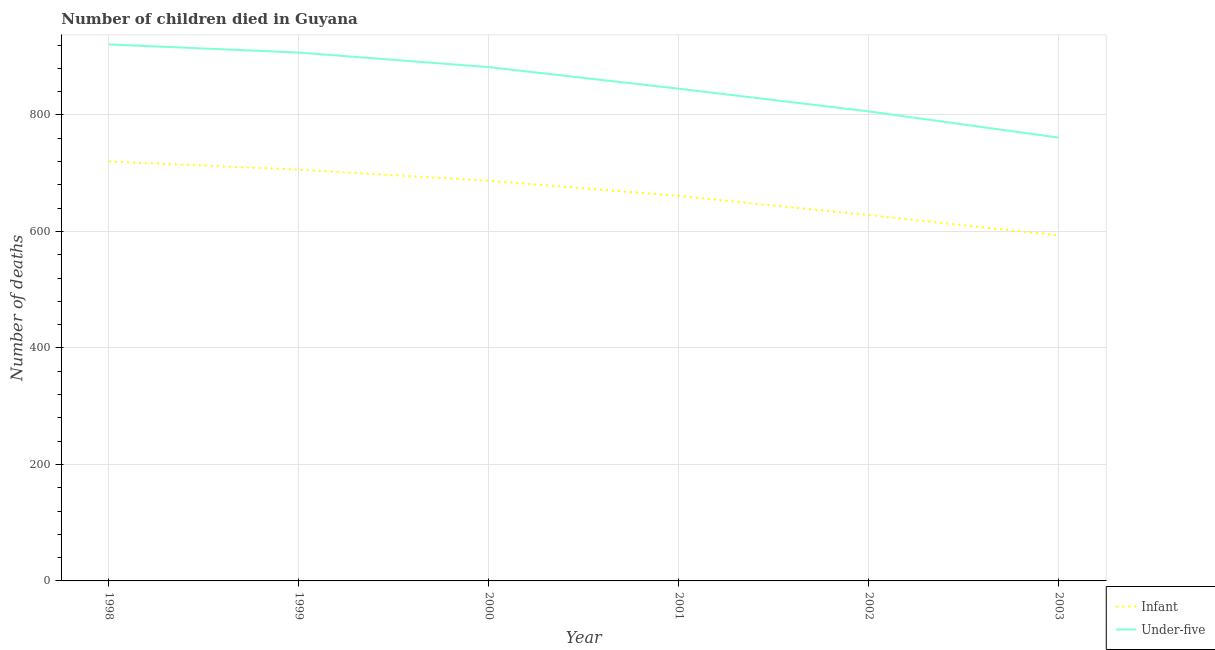Does the line corresponding to number of infant deaths intersect with the line corresponding to number of under-five deaths?
Make the answer very short. No. Is the number of lines equal to the number of legend labels?
Make the answer very short. Yes. What is the number of under-five deaths in 2002?
Your answer should be very brief. 806. Across all years, what is the maximum number of under-five deaths?
Your answer should be compact. 921. Across all years, what is the minimum number of under-five deaths?
Your answer should be very brief. 761. In which year was the number of under-five deaths minimum?
Make the answer very short. 2003. What is the total number of infant deaths in the graph?
Make the answer very short. 3995. What is the difference between the number of infant deaths in 1999 and that in 2002?
Keep it short and to the point. 78. What is the difference between the number of infant deaths in 1999 and the number of under-five deaths in 2001?
Provide a short and direct response. -139. What is the average number of under-five deaths per year?
Make the answer very short. 853.67. In the year 1998, what is the difference between the number of infant deaths and number of under-five deaths?
Your response must be concise. -201. What is the ratio of the number of under-five deaths in 2000 to that in 2002?
Ensure brevity in your answer.  1.09. Is the number of under-five deaths in 1999 less than that in 2000?
Your response must be concise. No. What is the difference between the highest and the lowest number of under-five deaths?
Give a very brief answer. 160. Is the sum of the number of under-five deaths in 2000 and 2003 greater than the maximum number of infant deaths across all years?
Offer a terse response. Yes. Does the number of infant deaths monotonically increase over the years?
Provide a succinct answer. No. Is the number of under-five deaths strictly less than the number of infant deaths over the years?
Your response must be concise. No. How many lines are there?
Your answer should be compact. 2. How many years are there in the graph?
Make the answer very short. 6. Does the graph contain any zero values?
Provide a short and direct response. No. How many legend labels are there?
Ensure brevity in your answer.  2. How are the legend labels stacked?
Give a very brief answer. Vertical. What is the title of the graph?
Keep it short and to the point. Number of children died in Guyana. What is the label or title of the Y-axis?
Offer a terse response. Number of deaths. What is the Number of deaths of Infant in 1998?
Make the answer very short. 720. What is the Number of deaths of Under-five in 1998?
Provide a succinct answer. 921. What is the Number of deaths of Infant in 1999?
Make the answer very short. 706. What is the Number of deaths in Under-five in 1999?
Your answer should be compact. 907. What is the Number of deaths of Infant in 2000?
Your response must be concise. 687. What is the Number of deaths of Under-five in 2000?
Offer a terse response. 882. What is the Number of deaths of Infant in 2001?
Give a very brief answer. 661. What is the Number of deaths of Under-five in 2001?
Keep it short and to the point. 845. What is the Number of deaths of Infant in 2002?
Offer a terse response. 628. What is the Number of deaths in Under-five in 2002?
Make the answer very short. 806. What is the Number of deaths of Infant in 2003?
Provide a short and direct response. 593. What is the Number of deaths in Under-five in 2003?
Provide a succinct answer. 761. Across all years, what is the maximum Number of deaths in Infant?
Keep it short and to the point. 720. Across all years, what is the maximum Number of deaths of Under-five?
Keep it short and to the point. 921. Across all years, what is the minimum Number of deaths in Infant?
Ensure brevity in your answer.  593. Across all years, what is the minimum Number of deaths in Under-five?
Keep it short and to the point. 761. What is the total Number of deaths in Infant in the graph?
Provide a succinct answer. 3995. What is the total Number of deaths in Under-five in the graph?
Offer a terse response. 5122. What is the difference between the Number of deaths in Infant in 1998 and that in 1999?
Offer a terse response. 14. What is the difference between the Number of deaths in Infant in 1998 and that in 2001?
Make the answer very short. 59. What is the difference between the Number of deaths in Under-five in 1998 and that in 2001?
Give a very brief answer. 76. What is the difference between the Number of deaths of Infant in 1998 and that in 2002?
Your answer should be compact. 92. What is the difference between the Number of deaths of Under-five in 1998 and that in 2002?
Offer a very short reply. 115. What is the difference between the Number of deaths in Infant in 1998 and that in 2003?
Provide a succinct answer. 127. What is the difference between the Number of deaths in Under-five in 1998 and that in 2003?
Offer a terse response. 160. What is the difference between the Number of deaths of Infant in 1999 and that in 2000?
Provide a succinct answer. 19. What is the difference between the Number of deaths of Under-five in 1999 and that in 2000?
Your answer should be compact. 25. What is the difference between the Number of deaths in Infant in 1999 and that in 2001?
Provide a short and direct response. 45. What is the difference between the Number of deaths of Under-five in 1999 and that in 2001?
Keep it short and to the point. 62. What is the difference between the Number of deaths in Infant in 1999 and that in 2002?
Your response must be concise. 78. What is the difference between the Number of deaths in Under-five in 1999 and that in 2002?
Your answer should be very brief. 101. What is the difference between the Number of deaths of Infant in 1999 and that in 2003?
Your response must be concise. 113. What is the difference between the Number of deaths in Under-five in 1999 and that in 2003?
Ensure brevity in your answer.  146. What is the difference between the Number of deaths in Infant in 2000 and that in 2001?
Your response must be concise. 26. What is the difference between the Number of deaths of Under-five in 2000 and that in 2002?
Keep it short and to the point. 76. What is the difference between the Number of deaths in Infant in 2000 and that in 2003?
Your answer should be very brief. 94. What is the difference between the Number of deaths in Under-five in 2000 and that in 2003?
Your answer should be very brief. 121. What is the difference between the Number of deaths of Infant in 2001 and that in 2002?
Ensure brevity in your answer.  33. What is the difference between the Number of deaths in Under-five in 2001 and that in 2002?
Offer a terse response. 39. What is the difference between the Number of deaths in Infant in 2001 and that in 2003?
Your response must be concise. 68. What is the difference between the Number of deaths of Under-five in 2001 and that in 2003?
Offer a very short reply. 84. What is the difference between the Number of deaths in Infant in 1998 and the Number of deaths in Under-five in 1999?
Offer a terse response. -187. What is the difference between the Number of deaths of Infant in 1998 and the Number of deaths of Under-five in 2000?
Your response must be concise. -162. What is the difference between the Number of deaths in Infant in 1998 and the Number of deaths in Under-five in 2001?
Provide a succinct answer. -125. What is the difference between the Number of deaths in Infant in 1998 and the Number of deaths in Under-five in 2002?
Provide a succinct answer. -86. What is the difference between the Number of deaths in Infant in 1998 and the Number of deaths in Under-five in 2003?
Keep it short and to the point. -41. What is the difference between the Number of deaths of Infant in 1999 and the Number of deaths of Under-five in 2000?
Offer a very short reply. -176. What is the difference between the Number of deaths in Infant in 1999 and the Number of deaths in Under-five in 2001?
Your answer should be compact. -139. What is the difference between the Number of deaths in Infant in 1999 and the Number of deaths in Under-five in 2002?
Offer a terse response. -100. What is the difference between the Number of deaths of Infant in 1999 and the Number of deaths of Under-five in 2003?
Your response must be concise. -55. What is the difference between the Number of deaths in Infant in 2000 and the Number of deaths in Under-five in 2001?
Ensure brevity in your answer.  -158. What is the difference between the Number of deaths in Infant in 2000 and the Number of deaths in Under-five in 2002?
Keep it short and to the point. -119. What is the difference between the Number of deaths in Infant in 2000 and the Number of deaths in Under-five in 2003?
Offer a very short reply. -74. What is the difference between the Number of deaths in Infant in 2001 and the Number of deaths in Under-five in 2002?
Your response must be concise. -145. What is the difference between the Number of deaths of Infant in 2001 and the Number of deaths of Under-five in 2003?
Your response must be concise. -100. What is the difference between the Number of deaths of Infant in 2002 and the Number of deaths of Under-five in 2003?
Offer a terse response. -133. What is the average Number of deaths in Infant per year?
Keep it short and to the point. 665.83. What is the average Number of deaths of Under-five per year?
Make the answer very short. 853.67. In the year 1998, what is the difference between the Number of deaths of Infant and Number of deaths of Under-five?
Offer a terse response. -201. In the year 1999, what is the difference between the Number of deaths of Infant and Number of deaths of Under-five?
Give a very brief answer. -201. In the year 2000, what is the difference between the Number of deaths of Infant and Number of deaths of Under-five?
Keep it short and to the point. -195. In the year 2001, what is the difference between the Number of deaths in Infant and Number of deaths in Under-five?
Your answer should be very brief. -184. In the year 2002, what is the difference between the Number of deaths of Infant and Number of deaths of Under-five?
Your response must be concise. -178. In the year 2003, what is the difference between the Number of deaths of Infant and Number of deaths of Under-five?
Give a very brief answer. -168. What is the ratio of the Number of deaths in Infant in 1998 to that in 1999?
Make the answer very short. 1.02. What is the ratio of the Number of deaths in Under-five in 1998 to that in 1999?
Your response must be concise. 1.02. What is the ratio of the Number of deaths of Infant in 1998 to that in 2000?
Give a very brief answer. 1.05. What is the ratio of the Number of deaths in Under-five in 1998 to that in 2000?
Make the answer very short. 1.04. What is the ratio of the Number of deaths in Infant in 1998 to that in 2001?
Make the answer very short. 1.09. What is the ratio of the Number of deaths of Under-five in 1998 to that in 2001?
Your answer should be very brief. 1.09. What is the ratio of the Number of deaths of Infant in 1998 to that in 2002?
Your response must be concise. 1.15. What is the ratio of the Number of deaths of Under-five in 1998 to that in 2002?
Offer a terse response. 1.14. What is the ratio of the Number of deaths in Infant in 1998 to that in 2003?
Offer a terse response. 1.21. What is the ratio of the Number of deaths in Under-five in 1998 to that in 2003?
Offer a very short reply. 1.21. What is the ratio of the Number of deaths of Infant in 1999 to that in 2000?
Offer a terse response. 1.03. What is the ratio of the Number of deaths in Under-five in 1999 to that in 2000?
Your answer should be compact. 1.03. What is the ratio of the Number of deaths in Infant in 1999 to that in 2001?
Provide a succinct answer. 1.07. What is the ratio of the Number of deaths of Under-five in 1999 to that in 2001?
Your answer should be very brief. 1.07. What is the ratio of the Number of deaths of Infant in 1999 to that in 2002?
Offer a terse response. 1.12. What is the ratio of the Number of deaths of Under-five in 1999 to that in 2002?
Keep it short and to the point. 1.13. What is the ratio of the Number of deaths in Infant in 1999 to that in 2003?
Your answer should be very brief. 1.19. What is the ratio of the Number of deaths in Under-five in 1999 to that in 2003?
Ensure brevity in your answer.  1.19. What is the ratio of the Number of deaths of Infant in 2000 to that in 2001?
Give a very brief answer. 1.04. What is the ratio of the Number of deaths in Under-five in 2000 to that in 2001?
Provide a succinct answer. 1.04. What is the ratio of the Number of deaths in Infant in 2000 to that in 2002?
Offer a terse response. 1.09. What is the ratio of the Number of deaths of Under-five in 2000 to that in 2002?
Your response must be concise. 1.09. What is the ratio of the Number of deaths of Infant in 2000 to that in 2003?
Offer a very short reply. 1.16. What is the ratio of the Number of deaths in Under-five in 2000 to that in 2003?
Make the answer very short. 1.16. What is the ratio of the Number of deaths in Infant in 2001 to that in 2002?
Give a very brief answer. 1.05. What is the ratio of the Number of deaths in Under-five in 2001 to that in 2002?
Offer a terse response. 1.05. What is the ratio of the Number of deaths in Infant in 2001 to that in 2003?
Make the answer very short. 1.11. What is the ratio of the Number of deaths of Under-five in 2001 to that in 2003?
Provide a short and direct response. 1.11. What is the ratio of the Number of deaths in Infant in 2002 to that in 2003?
Provide a succinct answer. 1.06. What is the ratio of the Number of deaths of Under-five in 2002 to that in 2003?
Your answer should be very brief. 1.06. What is the difference between the highest and the second highest Number of deaths in Infant?
Your response must be concise. 14. What is the difference between the highest and the lowest Number of deaths of Infant?
Make the answer very short. 127. What is the difference between the highest and the lowest Number of deaths of Under-five?
Your answer should be compact. 160. 